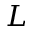<formula> <loc_0><loc_0><loc_500><loc_500>L</formula> 